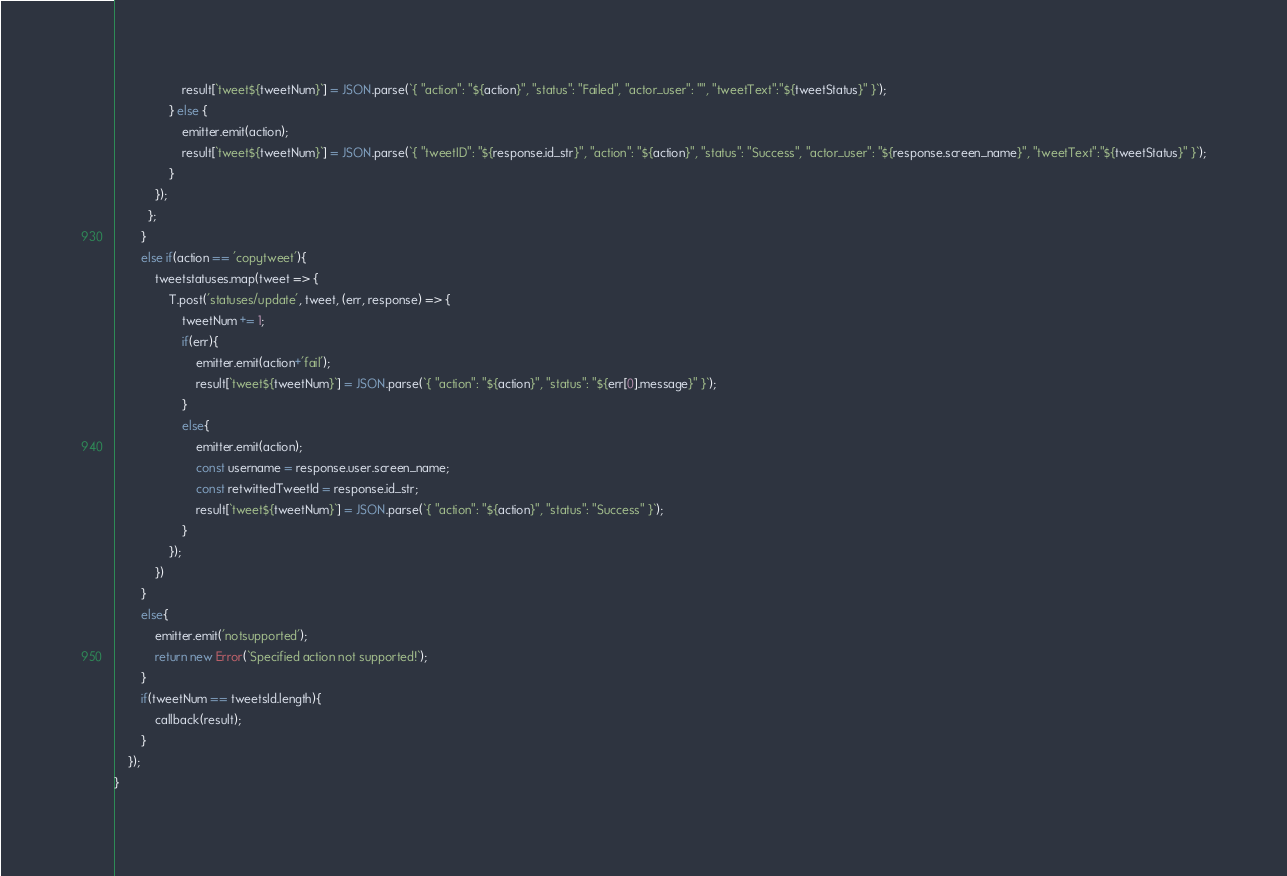Convert code to text. <code><loc_0><loc_0><loc_500><loc_500><_JavaScript_>                    result[`tweet${tweetNum}`] = JSON.parse(`{ "action": "${action}", "status": "Failed", "actor_user": "", "tweetText":"${tweetStatus}" }`);
                } else {
                    emitter.emit(action);
                    result[`tweet${tweetNum}`] = JSON.parse(`{ "tweetID": "${response.id_str}", "action": "${action}", "status": "Success", "actor_user": "${response.screen_name}", "tweetText":"${tweetStatus}" }`);
                }
            });
          };
        }
        else if(action == 'copytweet'){
            tweetstatuses.map(tweet => {
                T.post('statuses/update', tweet, (err, response) => {
                    tweetNum += 1;
                    if(err){
                        emitter.emit(action+'fail');
                        result[`tweet${tweetNum}`] = JSON.parse(`{ "action": "${action}", "status": "${err[0].message}" }`);
                    }
                    else{
                        emitter.emit(action);
                        const username = response.user.screen_name;
                        const retwittedTweetId = response.id_str;
                        result[`tweet${tweetNum}`] = JSON.parse(`{ "action": "${action}", "status": "Success" }`);
                    }
                });
            })
        }
        else{
            emitter.emit('notsupported');
            return new Error(`Specified action not supported!`);
        }
        if(tweetNum == tweetsId.length){
            callback(result);
        }
    });
}</code> 